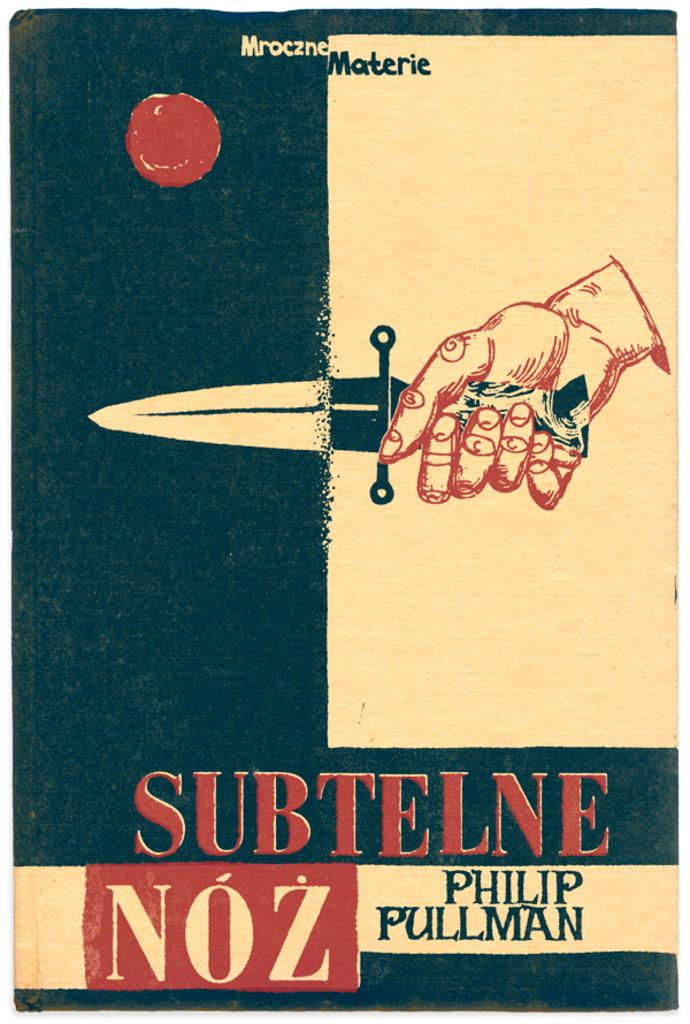<image>
Share a concise interpretation of the image provided. A yellow and black colored poster with a hand holding a knife above the word subtelne. 